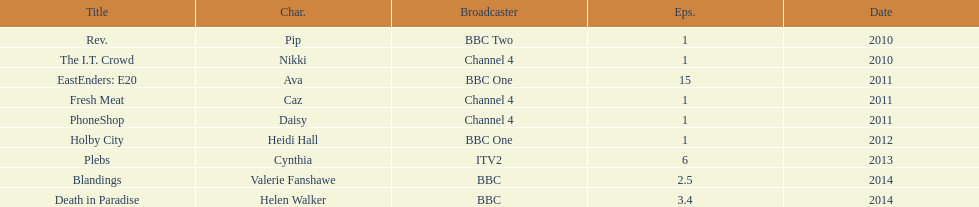What roles did she play? Pip, Nikki, Ava, Caz, Daisy, Heidi Hall, Cynthia, Valerie Fanshawe, Helen Walker. On which broadcasters? BBC Two, Channel 4, BBC One, Channel 4, Channel 4, BBC One, ITV2, BBC, BBC. Which roles did she play for itv2? Cynthia. 